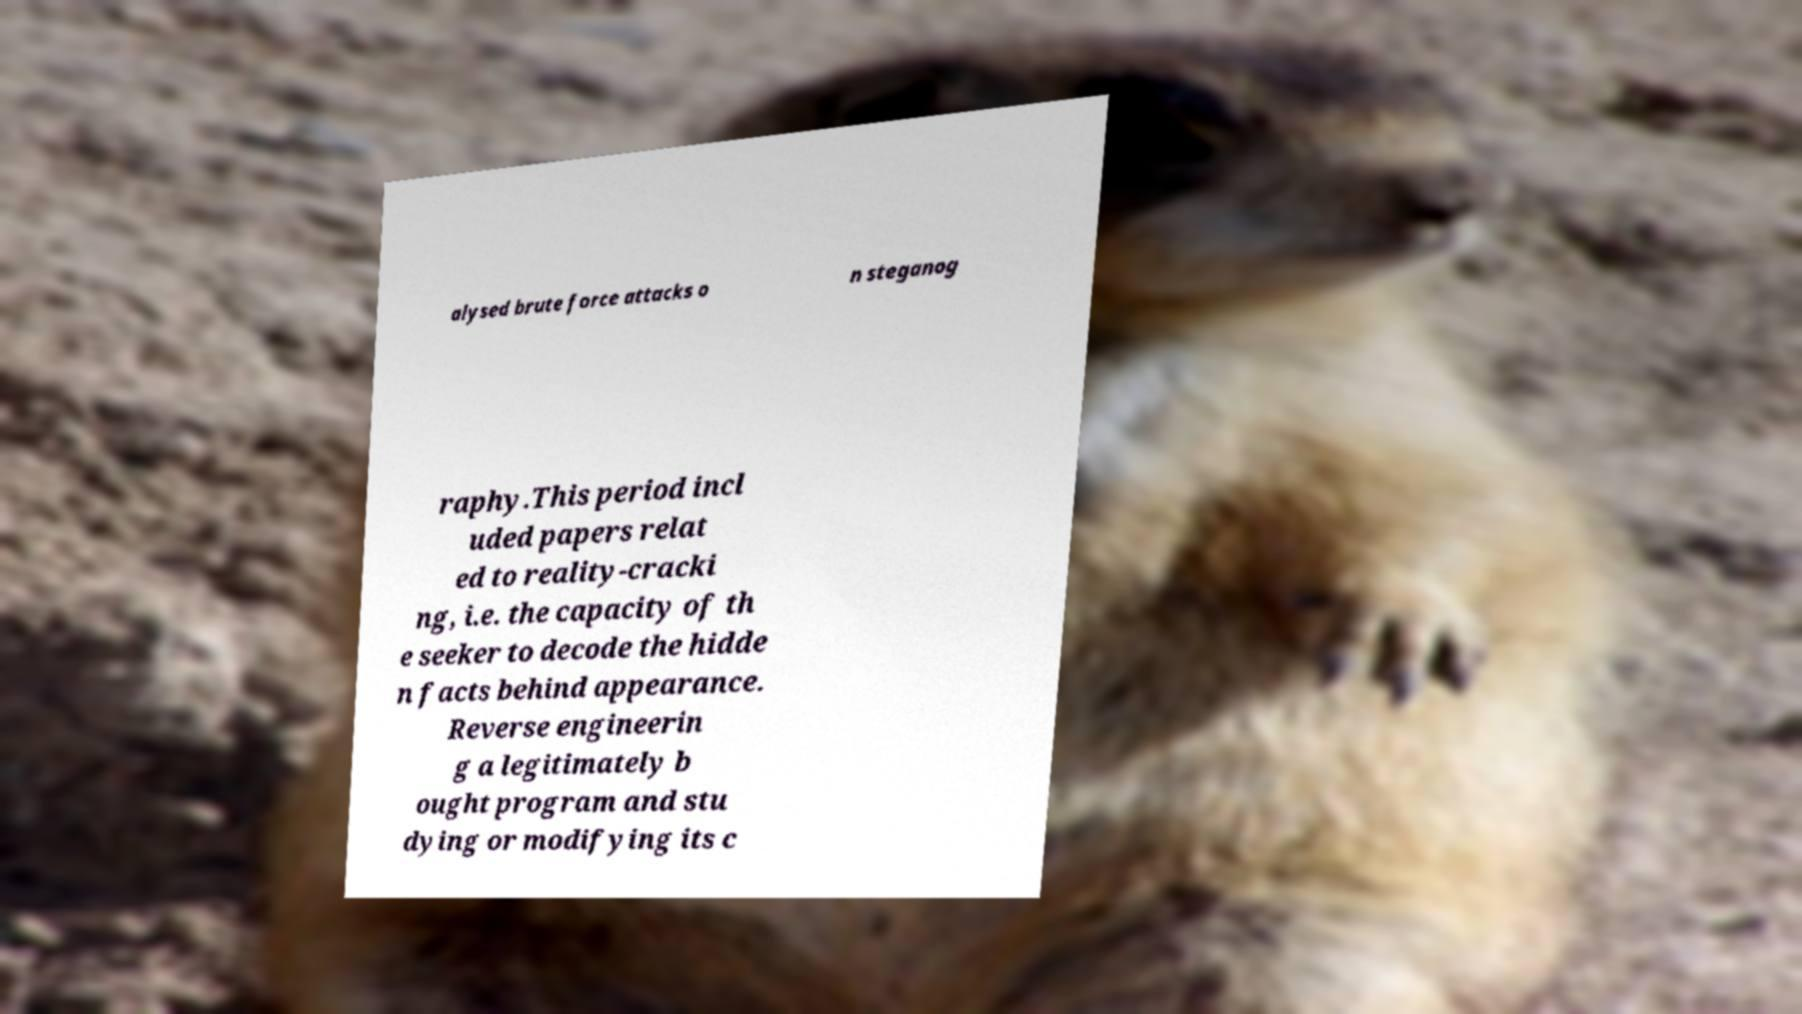For documentation purposes, I need the text within this image transcribed. Could you provide that? alysed brute force attacks o n steganog raphy.This period incl uded papers relat ed to reality-cracki ng, i.e. the capacity of th e seeker to decode the hidde n facts behind appearance. Reverse engineerin g a legitimately b ought program and stu dying or modifying its c 